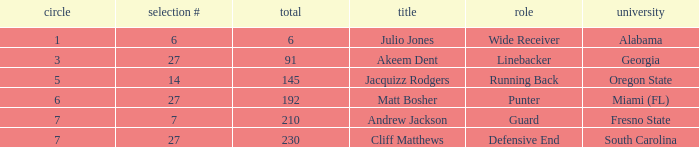Which name had more than 5 rounds and was a defensive end? Cliff Matthews. 